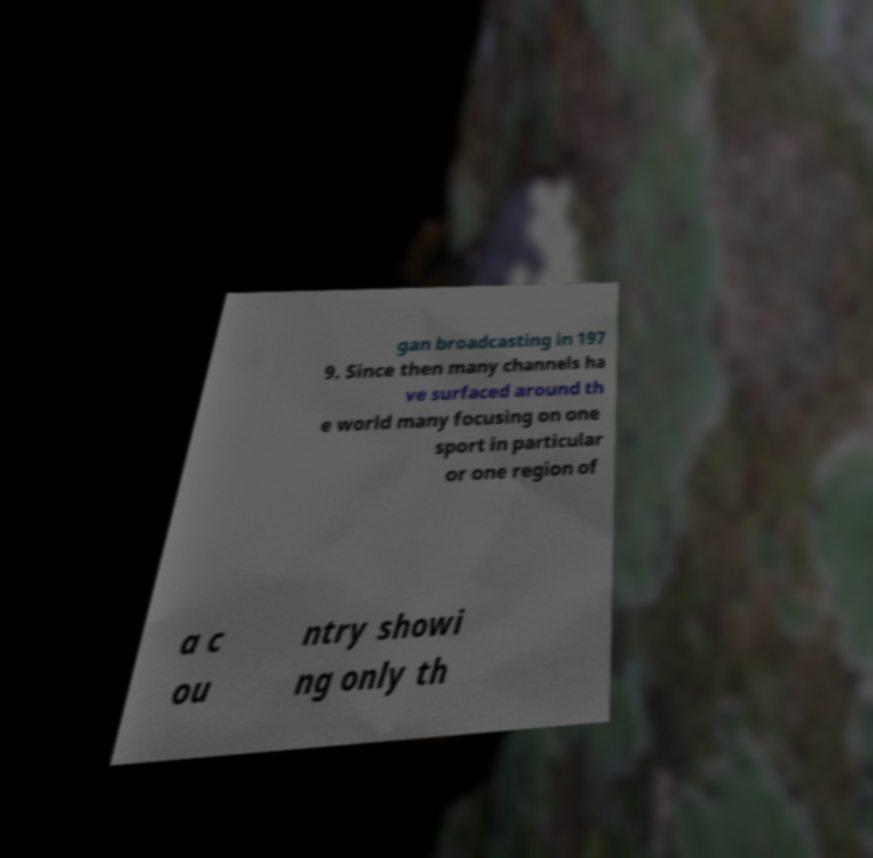Can you accurately transcribe the text from the provided image for me? gan broadcasting in 197 9. Since then many channels ha ve surfaced around th e world many focusing on one sport in particular or one region of a c ou ntry showi ng only th 